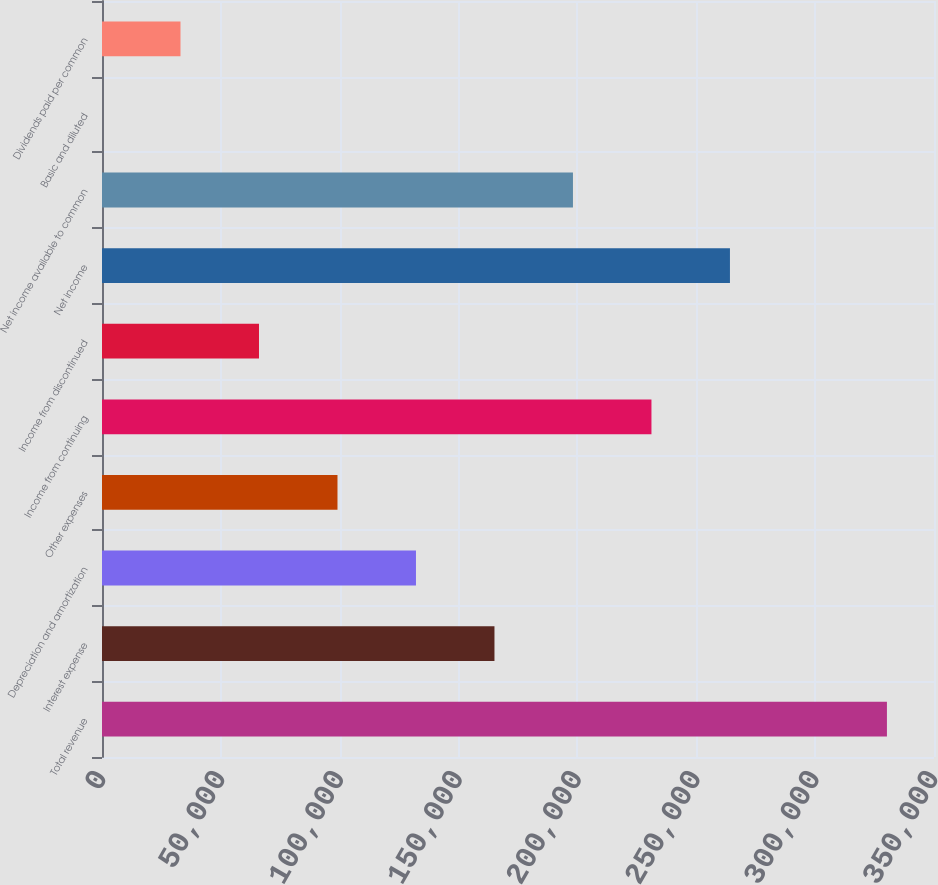Convert chart to OTSL. <chart><loc_0><loc_0><loc_500><loc_500><bar_chart><fcel>Total revenue<fcel>Interest expense<fcel>Depreciation and amortization<fcel>Other expenses<fcel>Income from continuing<fcel>Income from discontinued<fcel>Net income<fcel>Net income available to common<fcel>Basic and diluted<fcel>Dividends paid per common<nl><fcel>330200<fcel>165101<fcel>132081<fcel>99060.7<fcel>231140<fcel>66040.8<fcel>264160<fcel>198120<fcel>1.06<fcel>33020.9<nl></chart> 